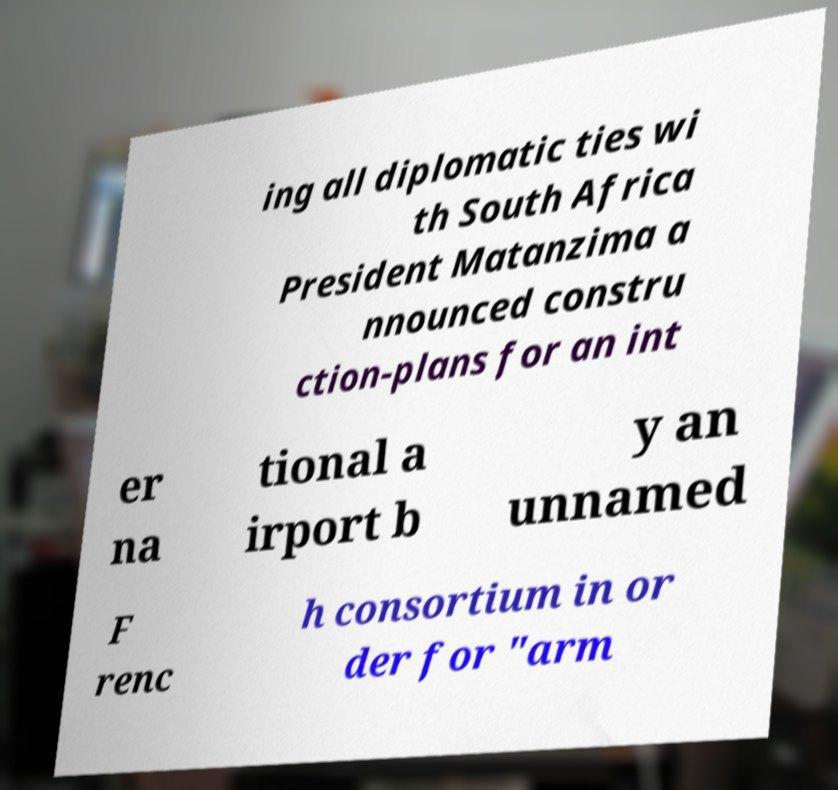Could you assist in decoding the text presented in this image and type it out clearly? ing all diplomatic ties wi th South Africa President Matanzima a nnounced constru ction-plans for an int er na tional a irport b y an unnamed F renc h consortium in or der for "arm 